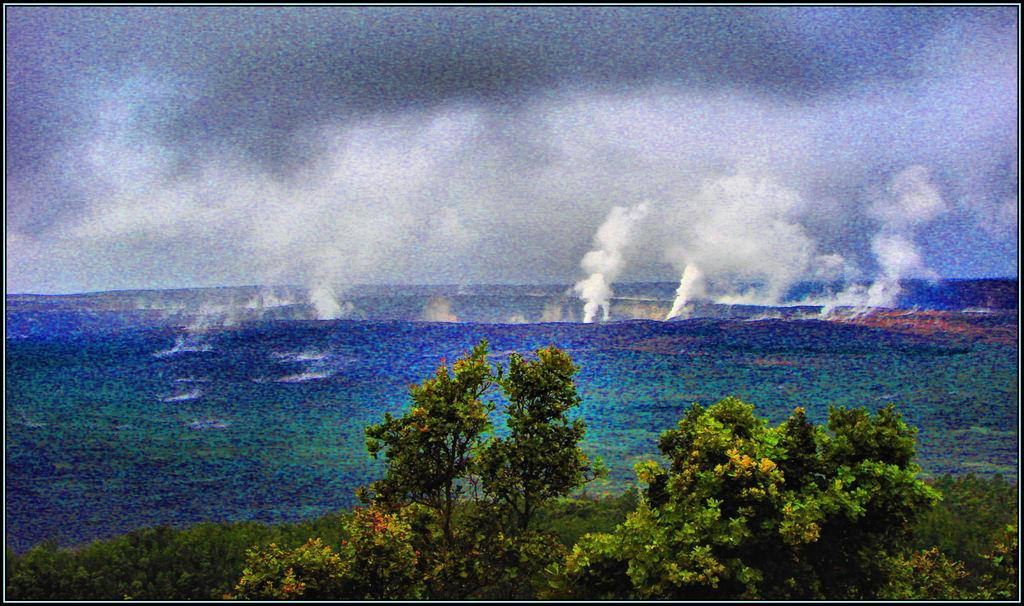What type of vegetation can be seen in the image? There are trees in the image. What natural element is visible in the image? There is water visible in the image. What is visible in the background of the image? The sky is visible in the background of the image. What can be seen in the sky in the image? There are clouds in the sky. What type of meal is being prepared in the image? There is no indication of a meal being prepared in the image; it features trees, water, sky, and clouds. Are there any slaves visible in the image? There is no reference to any slaves in the image; it features trees, water, sky, and clouds. 